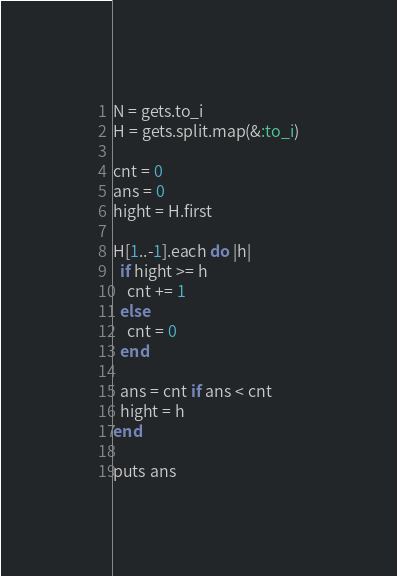<code> <loc_0><loc_0><loc_500><loc_500><_Ruby_>N = gets.to_i
H = gets.split.map(&:to_i)

cnt = 0
ans = 0
hight = H.first

H[1..-1].each do |h|
  if hight >= h
    cnt += 1
  else
    cnt = 0
  end

  ans = cnt if ans < cnt
  hight = h
end

puts ans
</code> 